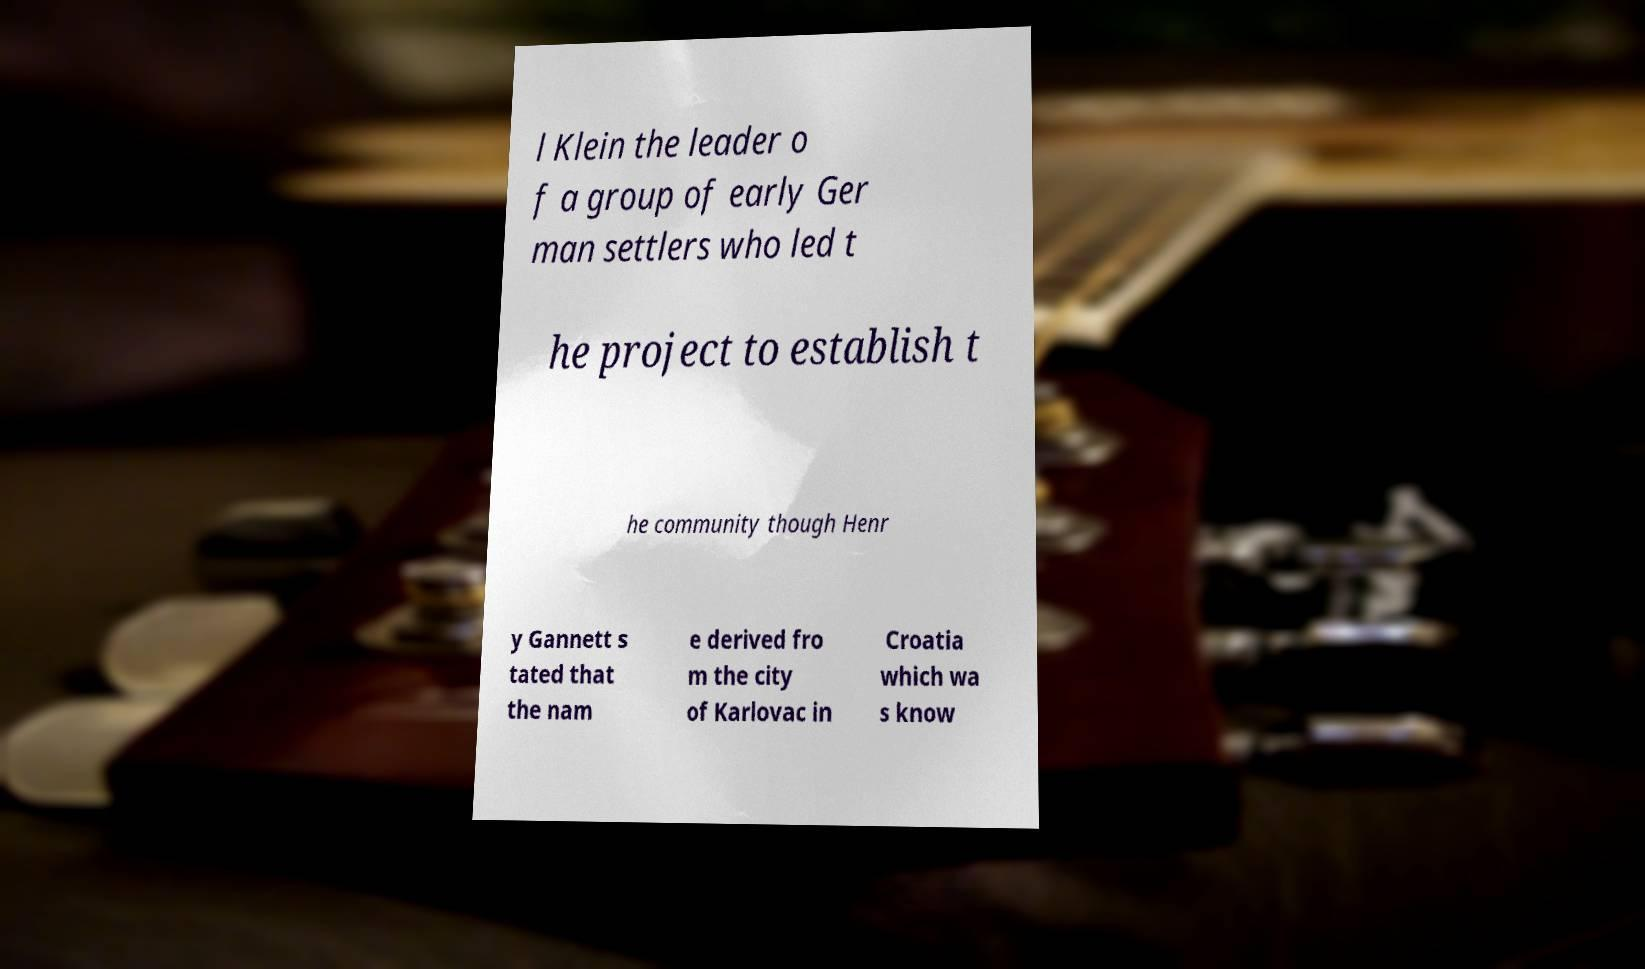I need the written content from this picture converted into text. Can you do that? l Klein the leader o f a group of early Ger man settlers who led t he project to establish t he community though Henr y Gannett s tated that the nam e derived fro m the city of Karlovac in Croatia which wa s know 